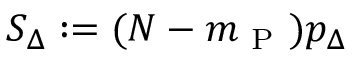Convert formula to latex. <formula><loc_0><loc_0><loc_500><loc_500>S _ { \Delta } \colon = ( N - m _ { P } ) p _ { \Delta }</formula> 